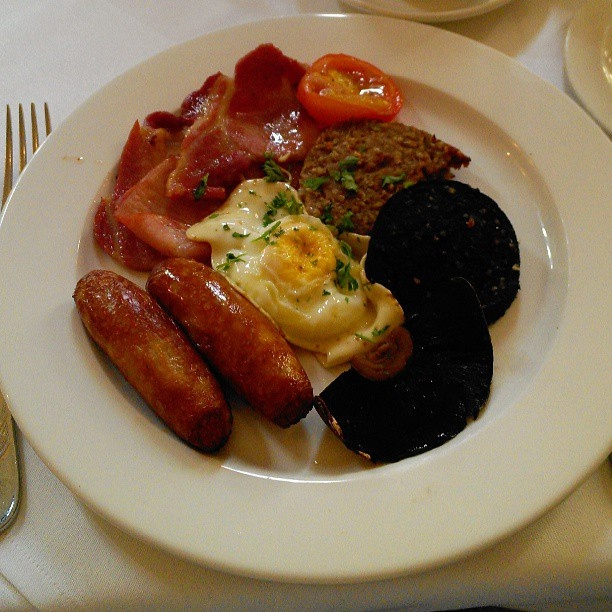Describe the objects in this image and their specific colors. I can see dining table in lightgray, olive, darkgray, tan, and gray tones and fork in lightgray, olive, gray, and tan tones in this image. 